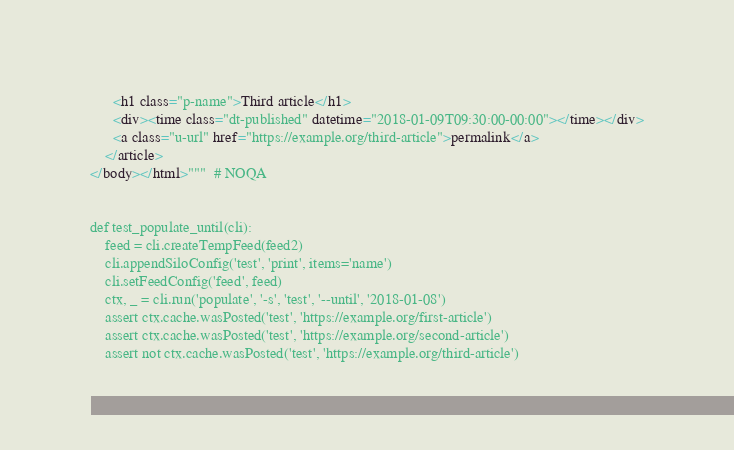<code> <loc_0><loc_0><loc_500><loc_500><_Python_>      <h1 class="p-name">Third article</h1>
      <div><time class="dt-published" datetime="2018-01-09T09:30:00-00:00"></time></div>
      <a class="u-url" href="https://example.org/third-article">permalink</a>
    </article>
</body></html>"""  # NOQA


def test_populate_until(cli):
    feed = cli.createTempFeed(feed2)
    cli.appendSiloConfig('test', 'print', items='name')
    cli.setFeedConfig('feed', feed)
    ctx, _ = cli.run('populate', '-s', 'test', '--until', '2018-01-08')
    assert ctx.cache.wasPosted('test', 'https://example.org/first-article')
    assert ctx.cache.wasPosted('test', 'https://example.org/second-article')
    assert not ctx.cache.wasPosted('test', 'https://example.org/third-article')
</code> 